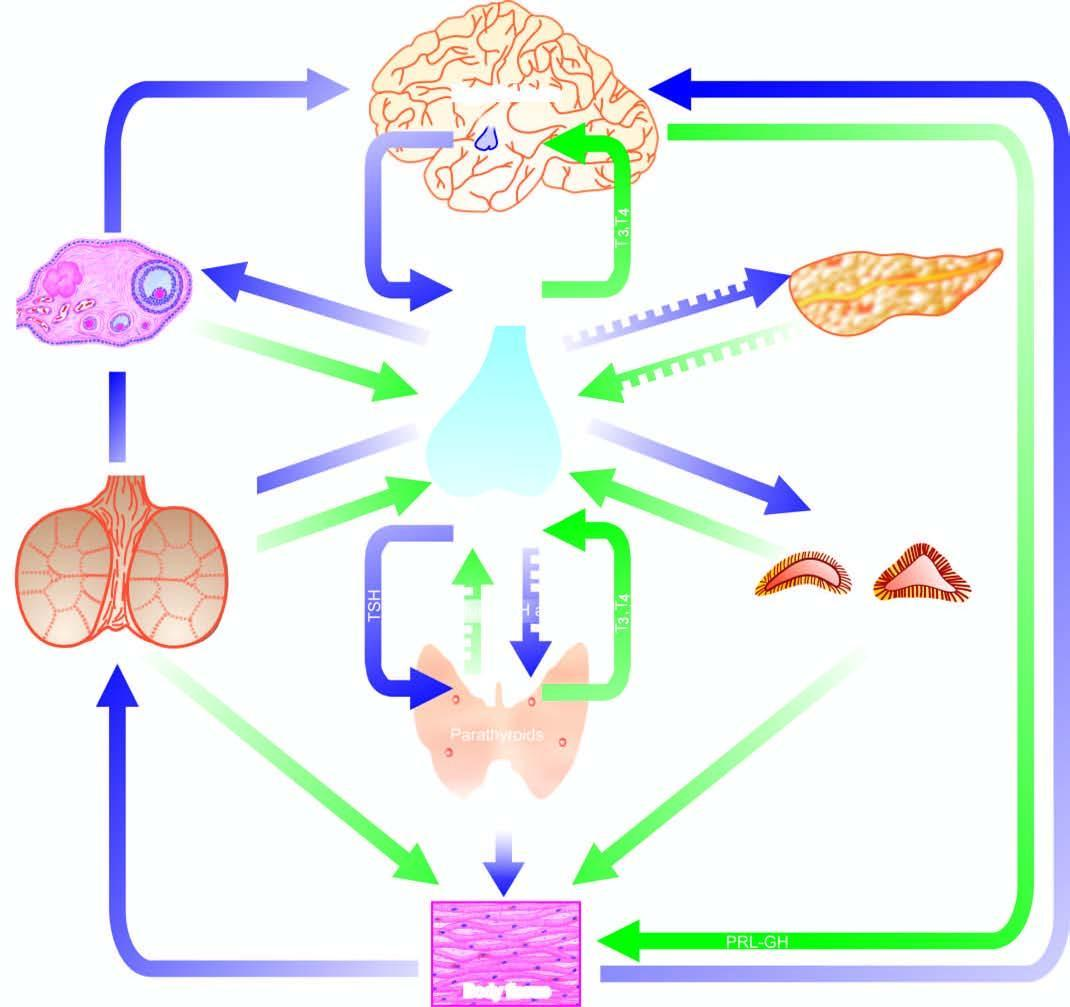what exist for each endocrine gland having a regulating hormone?
Answer the question using a single word or phrase. Both positive and negative feedback controls 